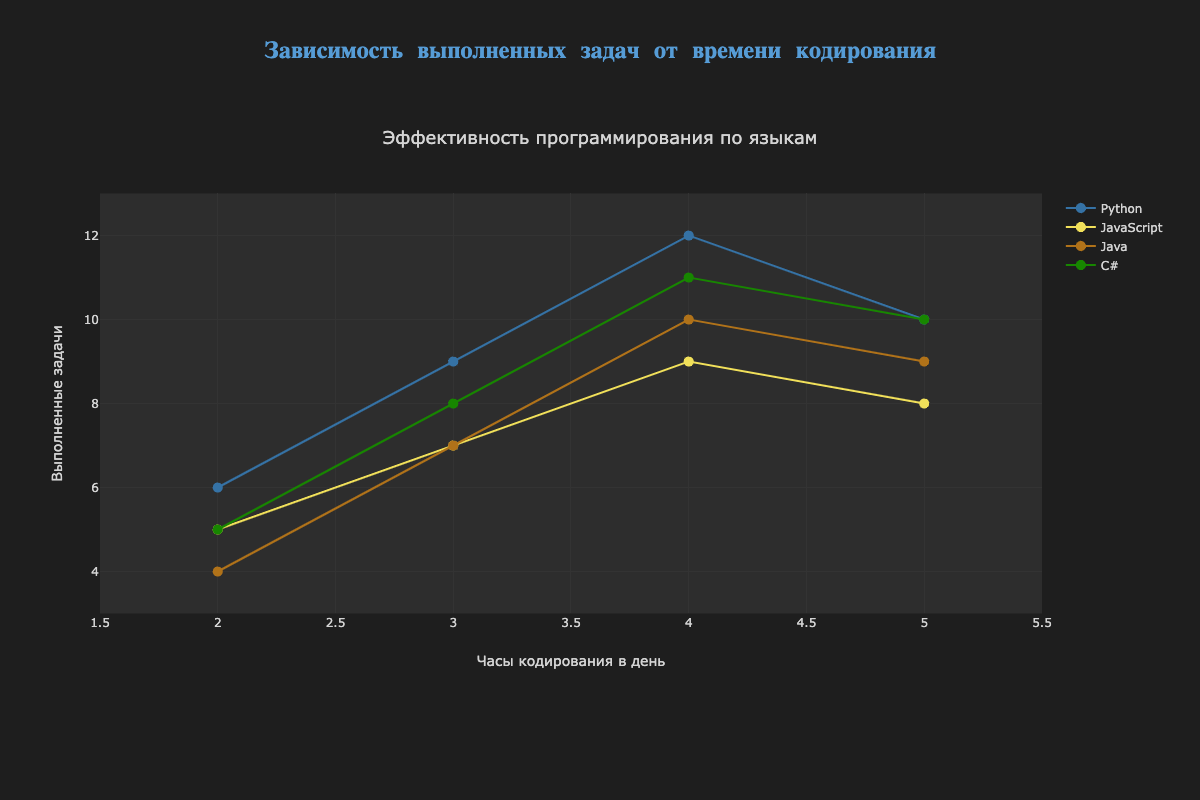What is the title of the chart? The title is located at the top of the chart and summarizes the overall content and aim of the graph.
Answer: Эффективность программирования по языкам What is the average number of completed tasks for Python when the daily coding hours are 3 and 4? For Python at daily coding hours 3 and 4, the completed tasks are 9 and 12. Average is calculated by (9 + 12) / 2 = 10.5
Answer: 10.5 Which programming language completed the most tasks at 2 daily coding hours? By checking the y-axis values for each language at 2 daily coding hours, Python has the highest value of 6 completed tasks.
Answer: Python How does the trend of JavaScript's completed tasks compare to that of C#? Both JavaScript and C# show a generally increasing trend in completed tasks as daily coding hours increase, but C# has a higher completion rate than JavaScript for the same number of hours.
Answer: C# has a higher completion rate Can you identify any anomalies in the data for Python's trend line? For Python, the trend suggests a linear increase, but at 5 daily coding hours, the number of completed tasks drops to 10, which deviates from the increasing trend.
Answer: Drop at 5 hours What’s the range of completed tasks for all languages combined? The y-axis shows completed tasks from a minimum of 4 (Java at 2 hours) to a maximum of 12 (Python at 4 hours). Thus, the range is 12 - 4 = 8.
Answer: 8 At what number of daily coding hours do both Java and C# have the same number of completed tasks? By examining the x-axis and finding intersecting points for Java and C# in the trend lines, both have 10 completed tasks at 5 daily coding hours.
Answer: 5 hours Which language has the most stable (least fluctuating) performance in terms of completed tasks? Stability can be judged by how consistently the number of completed tasks increases with daily coding hours. JavaScript shows the most balanced and steady rise without major deviations.
Answer: JavaScript How many languages have a peak of 10 completed tasks? By observing the peak points, Python, Java, and C# all reach 10 completed tasks.
Answer: 3 languages What is the overall trend shown by the scatter plot with trend lines? The overall trend indicates that generally, more daily coding hours correlate with more completed tasks, except for a few minor deviations.
Answer: Positive correlation 